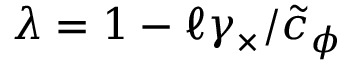<formula> <loc_0><loc_0><loc_500><loc_500>\lambda = 1 - \ell \gamma _ { \times } / \tilde { c } _ { \phi }</formula> 